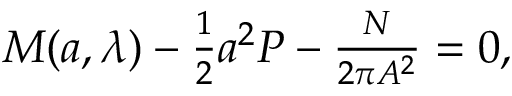Convert formula to latex. <formula><loc_0><loc_0><loc_500><loc_500>\begin{array} { r } { M ( { a } , \lambda ) - \frac { 1 } { 2 } { a } ^ { 2 } P - \frac { N } { 2 \pi A ^ { 2 } } = 0 , } \end{array}</formula> 